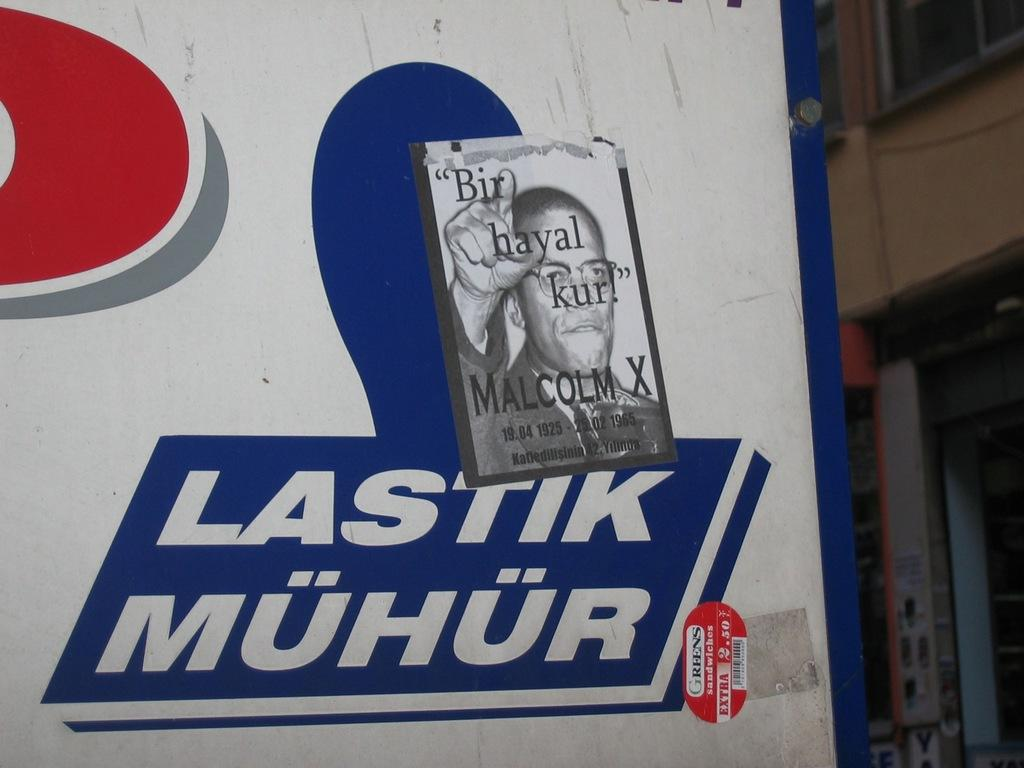What is on the board that is visible in the image? There is text on the board in the image. What other item can be seen in the image besides the board? There is a poster in the image. Where is the poster located in the image? The poster is located in the left corner of the image. What type of structure is visible in the image? There is a building in the image. What feature of the building can be observed? The building has windows. Where is the building located in the image? The building is located in the right corner of the image. How many bats are hanging from the building in the image? There are no bats visible in the image; it only features a board with text, a poster, and a building with windows. What type of bird can be seen flying near the poster in the image? There are no birds present in the image; it only features a board with text, a poster, and a building with windows. 